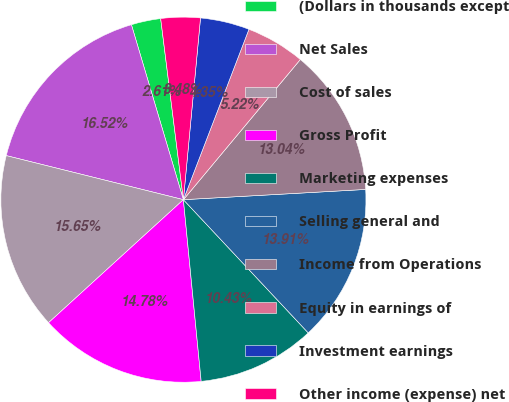<chart> <loc_0><loc_0><loc_500><loc_500><pie_chart><fcel>(Dollars in thousands except<fcel>Net Sales<fcel>Cost of sales<fcel>Gross Profit<fcel>Marketing expenses<fcel>Selling general and<fcel>Income from Operations<fcel>Equity in earnings of<fcel>Investment earnings<fcel>Other income (expense) net<nl><fcel>2.61%<fcel>16.52%<fcel>15.65%<fcel>14.78%<fcel>10.43%<fcel>13.91%<fcel>13.04%<fcel>5.22%<fcel>4.35%<fcel>3.48%<nl></chart> 